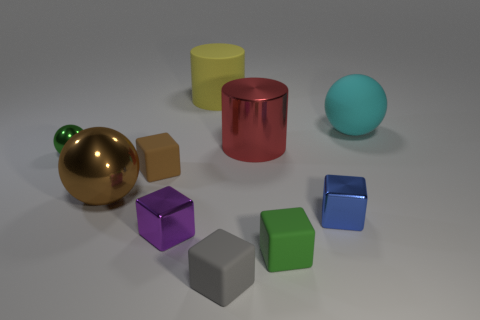Subtract all small blue cubes. How many cubes are left? 4 Subtract all yellow cubes. Subtract all brown spheres. How many cubes are left? 5 Subtract all balls. How many objects are left? 7 Add 2 green objects. How many green objects exist? 4 Subtract 0 gray spheres. How many objects are left? 10 Subtract all small cyan cubes. Subtract all big brown metal things. How many objects are left? 9 Add 4 tiny blue metal objects. How many tiny blue metal objects are left? 5 